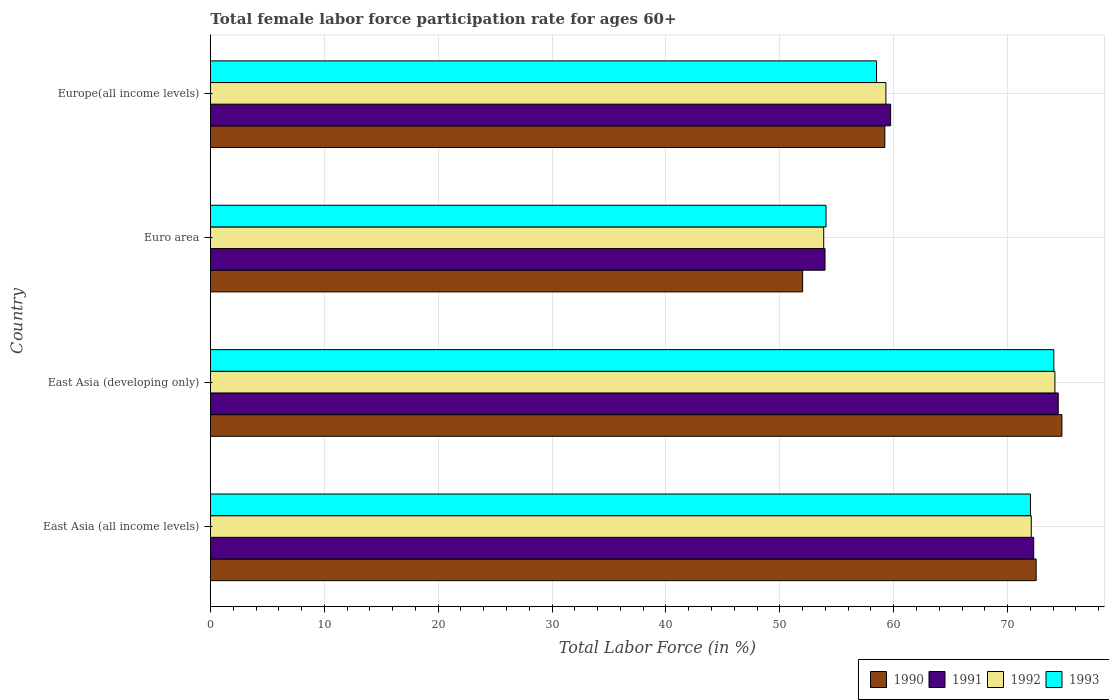How many groups of bars are there?
Offer a very short reply. 4. Are the number of bars on each tick of the Y-axis equal?
Your answer should be compact. Yes. How many bars are there on the 3rd tick from the top?
Offer a terse response. 4. What is the label of the 3rd group of bars from the top?
Give a very brief answer. East Asia (developing only). What is the female labor force participation rate in 1993 in East Asia (all income levels)?
Make the answer very short. 72.02. Across all countries, what is the maximum female labor force participation rate in 1991?
Your answer should be very brief. 74.45. Across all countries, what is the minimum female labor force participation rate in 1993?
Offer a terse response. 54.06. In which country was the female labor force participation rate in 1991 maximum?
Make the answer very short. East Asia (developing only). In which country was the female labor force participation rate in 1990 minimum?
Your response must be concise. Euro area. What is the total female labor force participation rate in 1991 in the graph?
Give a very brief answer. 260.45. What is the difference between the female labor force participation rate in 1993 in East Asia (developing only) and that in Europe(all income levels)?
Offer a terse response. 15.57. What is the difference between the female labor force participation rate in 1993 in East Asia (all income levels) and the female labor force participation rate in 1991 in Europe(all income levels)?
Your answer should be very brief. 12.28. What is the average female labor force participation rate in 1991 per country?
Keep it short and to the point. 65.11. What is the difference between the female labor force participation rate in 1991 and female labor force participation rate in 1992 in Euro area?
Your answer should be very brief. 0.11. What is the ratio of the female labor force participation rate in 1990 in East Asia (all income levels) to that in East Asia (developing only)?
Offer a terse response. 0.97. What is the difference between the highest and the second highest female labor force participation rate in 1992?
Provide a succinct answer. 2.07. What is the difference between the highest and the lowest female labor force participation rate in 1990?
Offer a very short reply. 22.77. In how many countries, is the female labor force participation rate in 1991 greater than the average female labor force participation rate in 1991 taken over all countries?
Provide a short and direct response. 2. How many bars are there?
Your response must be concise. 16. Are all the bars in the graph horizontal?
Your answer should be compact. Yes. What is the difference between two consecutive major ticks on the X-axis?
Your response must be concise. 10. Are the values on the major ticks of X-axis written in scientific E-notation?
Ensure brevity in your answer.  No. Does the graph contain any zero values?
Offer a terse response. No. How many legend labels are there?
Give a very brief answer. 4. What is the title of the graph?
Offer a terse response. Total female labor force participation rate for ages 60+. What is the label or title of the Y-axis?
Offer a very short reply. Country. What is the Total Labor Force (in %) of 1990 in East Asia (all income levels)?
Provide a succinct answer. 72.51. What is the Total Labor Force (in %) in 1991 in East Asia (all income levels)?
Your answer should be very brief. 72.3. What is the Total Labor Force (in %) in 1992 in East Asia (all income levels)?
Offer a very short reply. 72.08. What is the Total Labor Force (in %) of 1993 in East Asia (all income levels)?
Provide a succinct answer. 72.02. What is the Total Labor Force (in %) in 1990 in East Asia (developing only)?
Keep it short and to the point. 74.77. What is the Total Labor Force (in %) of 1991 in East Asia (developing only)?
Offer a terse response. 74.45. What is the Total Labor Force (in %) of 1992 in East Asia (developing only)?
Keep it short and to the point. 74.16. What is the Total Labor Force (in %) of 1993 in East Asia (developing only)?
Your answer should be very brief. 74.06. What is the Total Labor Force (in %) of 1990 in Euro area?
Your answer should be compact. 52.01. What is the Total Labor Force (in %) in 1991 in Euro area?
Ensure brevity in your answer.  53.97. What is the Total Labor Force (in %) of 1992 in Euro area?
Ensure brevity in your answer.  53.86. What is the Total Labor Force (in %) of 1993 in Euro area?
Your answer should be very brief. 54.06. What is the Total Labor Force (in %) in 1990 in Europe(all income levels)?
Offer a very short reply. 59.22. What is the Total Labor Force (in %) in 1991 in Europe(all income levels)?
Your answer should be compact. 59.73. What is the Total Labor Force (in %) of 1992 in Europe(all income levels)?
Offer a very short reply. 59.32. What is the Total Labor Force (in %) of 1993 in Europe(all income levels)?
Your answer should be very brief. 58.5. Across all countries, what is the maximum Total Labor Force (in %) in 1990?
Your response must be concise. 74.77. Across all countries, what is the maximum Total Labor Force (in %) of 1991?
Your response must be concise. 74.45. Across all countries, what is the maximum Total Labor Force (in %) in 1992?
Give a very brief answer. 74.16. Across all countries, what is the maximum Total Labor Force (in %) of 1993?
Your answer should be compact. 74.06. Across all countries, what is the minimum Total Labor Force (in %) in 1990?
Keep it short and to the point. 52.01. Across all countries, what is the minimum Total Labor Force (in %) of 1991?
Give a very brief answer. 53.97. Across all countries, what is the minimum Total Labor Force (in %) in 1992?
Provide a short and direct response. 53.86. Across all countries, what is the minimum Total Labor Force (in %) in 1993?
Make the answer very short. 54.06. What is the total Total Labor Force (in %) in 1990 in the graph?
Give a very brief answer. 258.51. What is the total Total Labor Force (in %) of 1991 in the graph?
Offer a very short reply. 260.45. What is the total Total Labor Force (in %) of 1992 in the graph?
Give a very brief answer. 259.41. What is the total Total Labor Force (in %) of 1993 in the graph?
Your answer should be very brief. 258.64. What is the difference between the Total Labor Force (in %) of 1990 in East Asia (all income levels) and that in East Asia (developing only)?
Your answer should be compact. -2.26. What is the difference between the Total Labor Force (in %) of 1991 in East Asia (all income levels) and that in East Asia (developing only)?
Provide a succinct answer. -2.15. What is the difference between the Total Labor Force (in %) in 1992 in East Asia (all income levels) and that in East Asia (developing only)?
Give a very brief answer. -2.07. What is the difference between the Total Labor Force (in %) of 1993 in East Asia (all income levels) and that in East Asia (developing only)?
Your response must be concise. -2.05. What is the difference between the Total Labor Force (in %) in 1990 in East Asia (all income levels) and that in Euro area?
Provide a succinct answer. 20.51. What is the difference between the Total Labor Force (in %) of 1991 in East Asia (all income levels) and that in Euro area?
Give a very brief answer. 18.33. What is the difference between the Total Labor Force (in %) of 1992 in East Asia (all income levels) and that in Euro area?
Provide a succinct answer. 18.23. What is the difference between the Total Labor Force (in %) in 1993 in East Asia (all income levels) and that in Euro area?
Provide a succinct answer. 17.95. What is the difference between the Total Labor Force (in %) of 1990 in East Asia (all income levels) and that in Europe(all income levels)?
Give a very brief answer. 13.29. What is the difference between the Total Labor Force (in %) of 1991 in East Asia (all income levels) and that in Europe(all income levels)?
Provide a succinct answer. 12.56. What is the difference between the Total Labor Force (in %) in 1992 in East Asia (all income levels) and that in Europe(all income levels)?
Give a very brief answer. 12.77. What is the difference between the Total Labor Force (in %) of 1993 in East Asia (all income levels) and that in Europe(all income levels)?
Your answer should be very brief. 13.52. What is the difference between the Total Labor Force (in %) in 1990 in East Asia (developing only) and that in Euro area?
Your answer should be very brief. 22.77. What is the difference between the Total Labor Force (in %) in 1991 in East Asia (developing only) and that in Euro area?
Keep it short and to the point. 20.48. What is the difference between the Total Labor Force (in %) of 1992 in East Asia (developing only) and that in Euro area?
Keep it short and to the point. 20.3. What is the difference between the Total Labor Force (in %) in 1993 in East Asia (developing only) and that in Euro area?
Give a very brief answer. 20. What is the difference between the Total Labor Force (in %) in 1990 in East Asia (developing only) and that in Europe(all income levels)?
Keep it short and to the point. 15.55. What is the difference between the Total Labor Force (in %) of 1991 in East Asia (developing only) and that in Europe(all income levels)?
Your response must be concise. 14.72. What is the difference between the Total Labor Force (in %) of 1992 in East Asia (developing only) and that in Europe(all income levels)?
Your answer should be very brief. 14.84. What is the difference between the Total Labor Force (in %) of 1993 in East Asia (developing only) and that in Europe(all income levels)?
Give a very brief answer. 15.57. What is the difference between the Total Labor Force (in %) in 1990 in Euro area and that in Europe(all income levels)?
Your answer should be very brief. -7.22. What is the difference between the Total Labor Force (in %) of 1991 in Euro area and that in Europe(all income levels)?
Keep it short and to the point. -5.76. What is the difference between the Total Labor Force (in %) in 1992 in Euro area and that in Europe(all income levels)?
Provide a succinct answer. -5.46. What is the difference between the Total Labor Force (in %) in 1993 in Euro area and that in Europe(all income levels)?
Ensure brevity in your answer.  -4.44. What is the difference between the Total Labor Force (in %) of 1990 in East Asia (all income levels) and the Total Labor Force (in %) of 1991 in East Asia (developing only)?
Keep it short and to the point. -1.94. What is the difference between the Total Labor Force (in %) in 1990 in East Asia (all income levels) and the Total Labor Force (in %) in 1992 in East Asia (developing only)?
Offer a very short reply. -1.65. What is the difference between the Total Labor Force (in %) in 1990 in East Asia (all income levels) and the Total Labor Force (in %) in 1993 in East Asia (developing only)?
Keep it short and to the point. -1.55. What is the difference between the Total Labor Force (in %) of 1991 in East Asia (all income levels) and the Total Labor Force (in %) of 1992 in East Asia (developing only)?
Your answer should be very brief. -1.86. What is the difference between the Total Labor Force (in %) of 1991 in East Asia (all income levels) and the Total Labor Force (in %) of 1993 in East Asia (developing only)?
Your answer should be very brief. -1.77. What is the difference between the Total Labor Force (in %) of 1992 in East Asia (all income levels) and the Total Labor Force (in %) of 1993 in East Asia (developing only)?
Your answer should be compact. -1.98. What is the difference between the Total Labor Force (in %) in 1990 in East Asia (all income levels) and the Total Labor Force (in %) in 1991 in Euro area?
Ensure brevity in your answer.  18.54. What is the difference between the Total Labor Force (in %) of 1990 in East Asia (all income levels) and the Total Labor Force (in %) of 1992 in Euro area?
Your answer should be very brief. 18.66. What is the difference between the Total Labor Force (in %) in 1990 in East Asia (all income levels) and the Total Labor Force (in %) in 1993 in Euro area?
Offer a terse response. 18.45. What is the difference between the Total Labor Force (in %) in 1991 in East Asia (all income levels) and the Total Labor Force (in %) in 1992 in Euro area?
Keep it short and to the point. 18.44. What is the difference between the Total Labor Force (in %) of 1991 in East Asia (all income levels) and the Total Labor Force (in %) of 1993 in Euro area?
Keep it short and to the point. 18.24. What is the difference between the Total Labor Force (in %) of 1992 in East Asia (all income levels) and the Total Labor Force (in %) of 1993 in Euro area?
Offer a very short reply. 18.02. What is the difference between the Total Labor Force (in %) in 1990 in East Asia (all income levels) and the Total Labor Force (in %) in 1991 in Europe(all income levels)?
Provide a short and direct response. 12.78. What is the difference between the Total Labor Force (in %) of 1990 in East Asia (all income levels) and the Total Labor Force (in %) of 1992 in Europe(all income levels)?
Provide a succinct answer. 13.2. What is the difference between the Total Labor Force (in %) of 1990 in East Asia (all income levels) and the Total Labor Force (in %) of 1993 in Europe(all income levels)?
Provide a succinct answer. 14.02. What is the difference between the Total Labor Force (in %) in 1991 in East Asia (all income levels) and the Total Labor Force (in %) in 1992 in Europe(all income levels)?
Your answer should be compact. 12.98. What is the difference between the Total Labor Force (in %) of 1991 in East Asia (all income levels) and the Total Labor Force (in %) of 1993 in Europe(all income levels)?
Keep it short and to the point. 13.8. What is the difference between the Total Labor Force (in %) in 1992 in East Asia (all income levels) and the Total Labor Force (in %) in 1993 in Europe(all income levels)?
Your answer should be compact. 13.59. What is the difference between the Total Labor Force (in %) in 1990 in East Asia (developing only) and the Total Labor Force (in %) in 1991 in Euro area?
Keep it short and to the point. 20.8. What is the difference between the Total Labor Force (in %) in 1990 in East Asia (developing only) and the Total Labor Force (in %) in 1992 in Euro area?
Offer a terse response. 20.92. What is the difference between the Total Labor Force (in %) of 1990 in East Asia (developing only) and the Total Labor Force (in %) of 1993 in Euro area?
Keep it short and to the point. 20.71. What is the difference between the Total Labor Force (in %) of 1991 in East Asia (developing only) and the Total Labor Force (in %) of 1992 in Euro area?
Make the answer very short. 20.6. What is the difference between the Total Labor Force (in %) in 1991 in East Asia (developing only) and the Total Labor Force (in %) in 1993 in Euro area?
Provide a succinct answer. 20.39. What is the difference between the Total Labor Force (in %) of 1992 in East Asia (developing only) and the Total Labor Force (in %) of 1993 in Euro area?
Provide a short and direct response. 20.1. What is the difference between the Total Labor Force (in %) of 1990 in East Asia (developing only) and the Total Labor Force (in %) of 1991 in Europe(all income levels)?
Offer a very short reply. 15.04. What is the difference between the Total Labor Force (in %) in 1990 in East Asia (developing only) and the Total Labor Force (in %) in 1992 in Europe(all income levels)?
Give a very brief answer. 15.46. What is the difference between the Total Labor Force (in %) in 1990 in East Asia (developing only) and the Total Labor Force (in %) in 1993 in Europe(all income levels)?
Offer a very short reply. 16.28. What is the difference between the Total Labor Force (in %) of 1991 in East Asia (developing only) and the Total Labor Force (in %) of 1992 in Europe(all income levels)?
Provide a short and direct response. 15.14. What is the difference between the Total Labor Force (in %) in 1991 in East Asia (developing only) and the Total Labor Force (in %) in 1993 in Europe(all income levels)?
Provide a short and direct response. 15.96. What is the difference between the Total Labor Force (in %) in 1992 in East Asia (developing only) and the Total Labor Force (in %) in 1993 in Europe(all income levels)?
Your response must be concise. 15.66. What is the difference between the Total Labor Force (in %) of 1990 in Euro area and the Total Labor Force (in %) of 1991 in Europe(all income levels)?
Make the answer very short. -7.73. What is the difference between the Total Labor Force (in %) of 1990 in Euro area and the Total Labor Force (in %) of 1992 in Europe(all income levels)?
Offer a terse response. -7.31. What is the difference between the Total Labor Force (in %) of 1990 in Euro area and the Total Labor Force (in %) of 1993 in Europe(all income levels)?
Your answer should be compact. -6.49. What is the difference between the Total Labor Force (in %) of 1991 in Euro area and the Total Labor Force (in %) of 1992 in Europe(all income levels)?
Keep it short and to the point. -5.34. What is the difference between the Total Labor Force (in %) of 1991 in Euro area and the Total Labor Force (in %) of 1993 in Europe(all income levels)?
Your answer should be very brief. -4.53. What is the difference between the Total Labor Force (in %) of 1992 in Euro area and the Total Labor Force (in %) of 1993 in Europe(all income levels)?
Keep it short and to the point. -4.64. What is the average Total Labor Force (in %) of 1990 per country?
Provide a short and direct response. 64.63. What is the average Total Labor Force (in %) in 1991 per country?
Your answer should be compact. 65.11. What is the average Total Labor Force (in %) of 1992 per country?
Offer a very short reply. 64.85. What is the average Total Labor Force (in %) in 1993 per country?
Make the answer very short. 64.66. What is the difference between the Total Labor Force (in %) of 1990 and Total Labor Force (in %) of 1991 in East Asia (all income levels)?
Your answer should be very brief. 0.21. What is the difference between the Total Labor Force (in %) of 1990 and Total Labor Force (in %) of 1992 in East Asia (all income levels)?
Offer a terse response. 0.43. What is the difference between the Total Labor Force (in %) in 1990 and Total Labor Force (in %) in 1993 in East Asia (all income levels)?
Give a very brief answer. 0.5. What is the difference between the Total Labor Force (in %) in 1991 and Total Labor Force (in %) in 1992 in East Asia (all income levels)?
Keep it short and to the point. 0.21. What is the difference between the Total Labor Force (in %) in 1991 and Total Labor Force (in %) in 1993 in East Asia (all income levels)?
Your answer should be compact. 0.28. What is the difference between the Total Labor Force (in %) in 1992 and Total Labor Force (in %) in 1993 in East Asia (all income levels)?
Offer a very short reply. 0.07. What is the difference between the Total Labor Force (in %) of 1990 and Total Labor Force (in %) of 1991 in East Asia (developing only)?
Your response must be concise. 0.32. What is the difference between the Total Labor Force (in %) in 1990 and Total Labor Force (in %) in 1992 in East Asia (developing only)?
Provide a short and direct response. 0.62. What is the difference between the Total Labor Force (in %) of 1990 and Total Labor Force (in %) of 1993 in East Asia (developing only)?
Make the answer very short. 0.71. What is the difference between the Total Labor Force (in %) in 1991 and Total Labor Force (in %) in 1992 in East Asia (developing only)?
Make the answer very short. 0.29. What is the difference between the Total Labor Force (in %) in 1991 and Total Labor Force (in %) in 1993 in East Asia (developing only)?
Your response must be concise. 0.39. What is the difference between the Total Labor Force (in %) in 1992 and Total Labor Force (in %) in 1993 in East Asia (developing only)?
Your answer should be compact. 0.09. What is the difference between the Total Labor Force (in %) in 1990 and Total Labor Force (in %) in 1991 in Euro area?
Keep it short and to the point. -1.96. What is the difference between the Total Labor Force (in %) of 1990 and Total Labor Force (in %) of 1992 in Euro area?
Make the answer very short. -1.85. What is the difference between the Total Labor Force (in %) in 1990 and Total Labor Force (in %) in 1993 in Euro area?
Your answer should be very brief. -2.05. What is the difference between the Total Labor Force (in %) of 1991 and Total Labor Force (in %) of 1992 in Euro area?
Your response must be concise. 0.11. What is the difference between the Total Labor Force (in %) of 1991 and Total Labor Force (in %) of 1993 in Euro area?
Ensure brevity in your answer.  -0.09. What is the difference between the Total Labor Force (in %) in 1992 and Total Labor Force (in %) in 1993 in Euro area?
Make the answer very short. -0.2. What is the difference between the Total Labor Force (in %) of 1990 and Total Labor Force (in %) of 1991 in Europe(all income levels)?
Provide a short and direct response. -0.51. What is the difference between the Total Labor Force (in %) in 1990 and Total Labor Force (in %) in 1992 in Europe(all income levels)?
Provide a succinct answer. -0.09. What is the difference between the Total Labor Force (in %) of 1990 and Total Labor Force (in %) of 1993 in Europe(all income levels)?
Ensure brevity in your answer.  0.73. What is the difference between the Total Labor Force (in %) of 1991 and Total Labor Force (in %) of 1992 in Europe(all income levels)?
Offer a very short reply. 0.42. What is the difference between the Total Labor Force (in %) of 1991 and Total Labor Force (in %) of 1993 in Europe(all income levels)?
Provide a short and direct response. 1.24. What is the difference between the Total Labor Force (in %) of 1992 and Total Labor Force (in %) of 1993 in Europe(all income levels)?
Give a very brief answer. 0.82. What is the ratio of the Total Labor Force (in %) of 1990 in East Asia (all income levels) to that in East Asia (developing only)?
Your answer should be very brief. 0.97. What is the ratio of the Total Labor Force (in %) of 1991 in East Asia (all income levels) to that in East Asia (developing only)?
Offer a very short reply. 0.97. What is the ratio of the Total Labor Force (in %) in 1992 in East Asia (all income levels) to that in East Asia (developing only)?
Your response must be concise. 0.97. What is the ratio of the Total Labor Force (in %) in 1993 in East Asia (all income levels) to that in East Asia (developing only)?
Your answer should be compact. 0.97. What is the ratio of the Total Labor Force (in %) of 1990 in East Asia (all income levels) to that in Euro area?
Offer a very short reply. 1.39. What is the ratio of the Total Labor Force (in %) of 1991 in East Asia (all income levels) to that in Euro area?
Offer a terse response. 1.34. What is the ratio of the Total Labor Force (in %) of 1992 in East Asia (all income levels) to that in Euro area?
Provide a short and direct response. 1.34. What is the ratio of the Total Labor Force (in %) in 1993 in East Asia (all income levels) to that in Euro area?
Make the answer very short. 1.33. What is the ratio of the Total Labor Force (in %) in 1990 in East Asia (all income levels) to that in Europe(all income levels)?
Your response must be concise. 1.22. What is the ratio of the Total Labor Force (in %) in 1991 in East Asia (all income levels) to that in Europe(all income levels)?
Provide a short and direct response. 1.21. What is the ratio of the Total Labor Force (in %) of 1992 in East Asia (all income levels) to that in Europe(all income levels)?
Keep it short and to the point. 1.22. What is the ratio of the Total Labor Force (in %) in 1993 in East Asia (all income levels) to that in Europe(all income levels)?
Your answer should be compact. 1.23. What is the ratio of the Total Labor Force (in %) of 1990 in East Asia (developing only) to that in Euro area?
Your answer should be compact. 1.44. What is the ratio of the Total Labor Force (in %) in 1991 in East Asia (developing only) to that in Euro area?
Offer a very short reply. 1.38. What is the ratio of the Total Labor Force (in %) of 1992 in East Asia (developing only) to that in Euro area?
Your response must be concise. 1.38. What is the ratio of the Total Labor Force (in %) of 1993 in East Asia (developing only) to that in Euro area?
Offer a terse response. 1.37. What is the ratio of the Total Labor Force (in %) in 1990 in East Asia (developing only) to that in Europe(all income levels)?
Your response must be concise. 1.26. What is the ratio of the Total Labor Force (in %) in 1991 in East Asia (developing only) to that in Europe(all income levels)?
Provide a short and direct response. 1.25. What is the ratio of the Total Labor Force (in %) in 1992 in East Asia (developing only) to that in Europe(all income levels)?
Your answer should be very brief. 1.25. What is the ratio of the Total Labor Force (in %) in 1993 in East Asia (developing only) to that in Europe(all income levels)?
Make the answer very short. 1.27. What is the ratio of the Total Labor Force (in %) in 1990 in Euro area to that in Europe(all income levels)?
Offer a terse response. 0.88. What is the ratio of the Total Labor Force (in %) in 1991 in Euro area to that in Europe(all income levels)?
Offer a terse response. 0.9. What is the ratio of the Total Labor Force (in %) in 1992 in Euro area to that in Europe(all income levels)?
Make the answer very short. 0.91. What is the ratio of the Total Labor Force (in %) in 1993 in Euro area to that in Europe(all income levels)?
Your answer should be very brief. 0.92. What is the difference between the highest and the second highest Total Labor Force (in %) of 1990?
Your answer should be very brief. 2.26. What is the difference between the highest and the second highest Total Labor Force (in %) in 1991?
Keep it short and to the point. 2.15. What is the difference between the highest and the second highest Total Labor Force (in %) in 1992?
Keep it short and to the point. 2.07. What is the difference between the highest and the second highest Total Labor Force (in %) in 1993?
Provide a succinct answer. 2.05. What is the difference between the highest and the lowest Total Labor Force (in %) in 1990?
Keep it short and to the point. 22.77. What is the difference between the highest and the lowest Total Labor Force (in %) of 1991?
Your answer should be very brief. 20.48. What is the difference between the highest and the lowest Total Labor Force (in %) of 1992?
Your response must be concise. 20.3. What is the difference between the highest and the lowest Total Labor Force (in %) in 1993?
Your answer should be very brief. 20. 